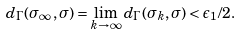<formula> <loc_0><loc_0><loc_500><loc_500>d _ { \Gamma } ( \sigma _ { \infty } , \sigma ) = \lim _ { k \to \infty } d _ { \Gamma } ( \sigma _ { k } , \sigma ) < \epsilon _ { 1 } / 2 .</formula> 